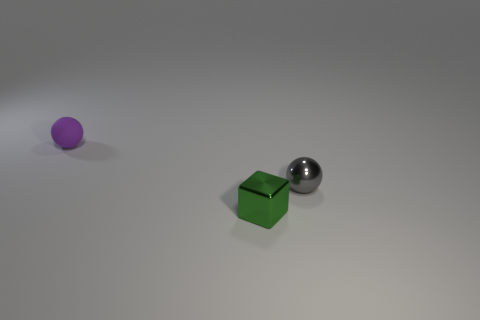What is the material of the ball that is to the left of the gray ball?
Keep it short and to the point. Rubber. Is there a small gray shiny thing that has the same shape as the tiny green metallic thing?
Provide a succinct answer. No. How many tiny green things have the same shape as the gray metallic thing?
Offer a very short reply. 0. There is a ball in front of the matte sphere; does it have the same size as the ball left of the small green shiny block?
Provide a short and direct response. Yes. There is a object that is in front of the small sphere on the right side of the small matte sphere; what is its shape?
Ensure brevity in your answer.  Cube. Are there the same number of purple matte spheres that are to the right of the small matte sphere and big green matte objects?
Provide a succinct answer. Yes. There is a small thing that is left of the small shiny object on the left side of the tiny ball that is on the right side of the tiny matte thing; what is it made of?
Provide a short and direct response. Rubber. Are there any purple rubber objects of the same size as the purple rubber ball?
Provide a short and direct response. No. What is the shape of the small green object?
Keep it short and to the point. Cube. How many cubes are shiny objects or tiny green metallic things?
Offer a terse response. 1. 